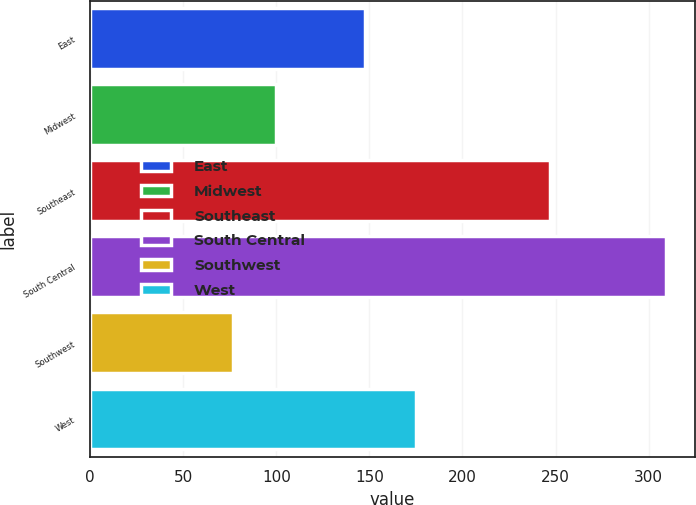Convert chart. <chart><loc_0><loc_0><loc_500><loc_500><bar_chart><fcel>East<fcel>Midwest<fcel>Southeast<fcel>South Central<fcel>Southwest<fcel>West<nl><fcel>147.6<fcel>99.89<fcel>246.9<fcel>309.5<fcel>76.6<fcel>175<nl></chart> 